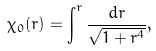<formula> <loc_0><loc_0><loc_500><loc_500>\chi _ { 0 } ( r ) = \int ^ { r } \frac { d r } { \sqrt { 1 + r ^ { 4 } } } ,</formula> 